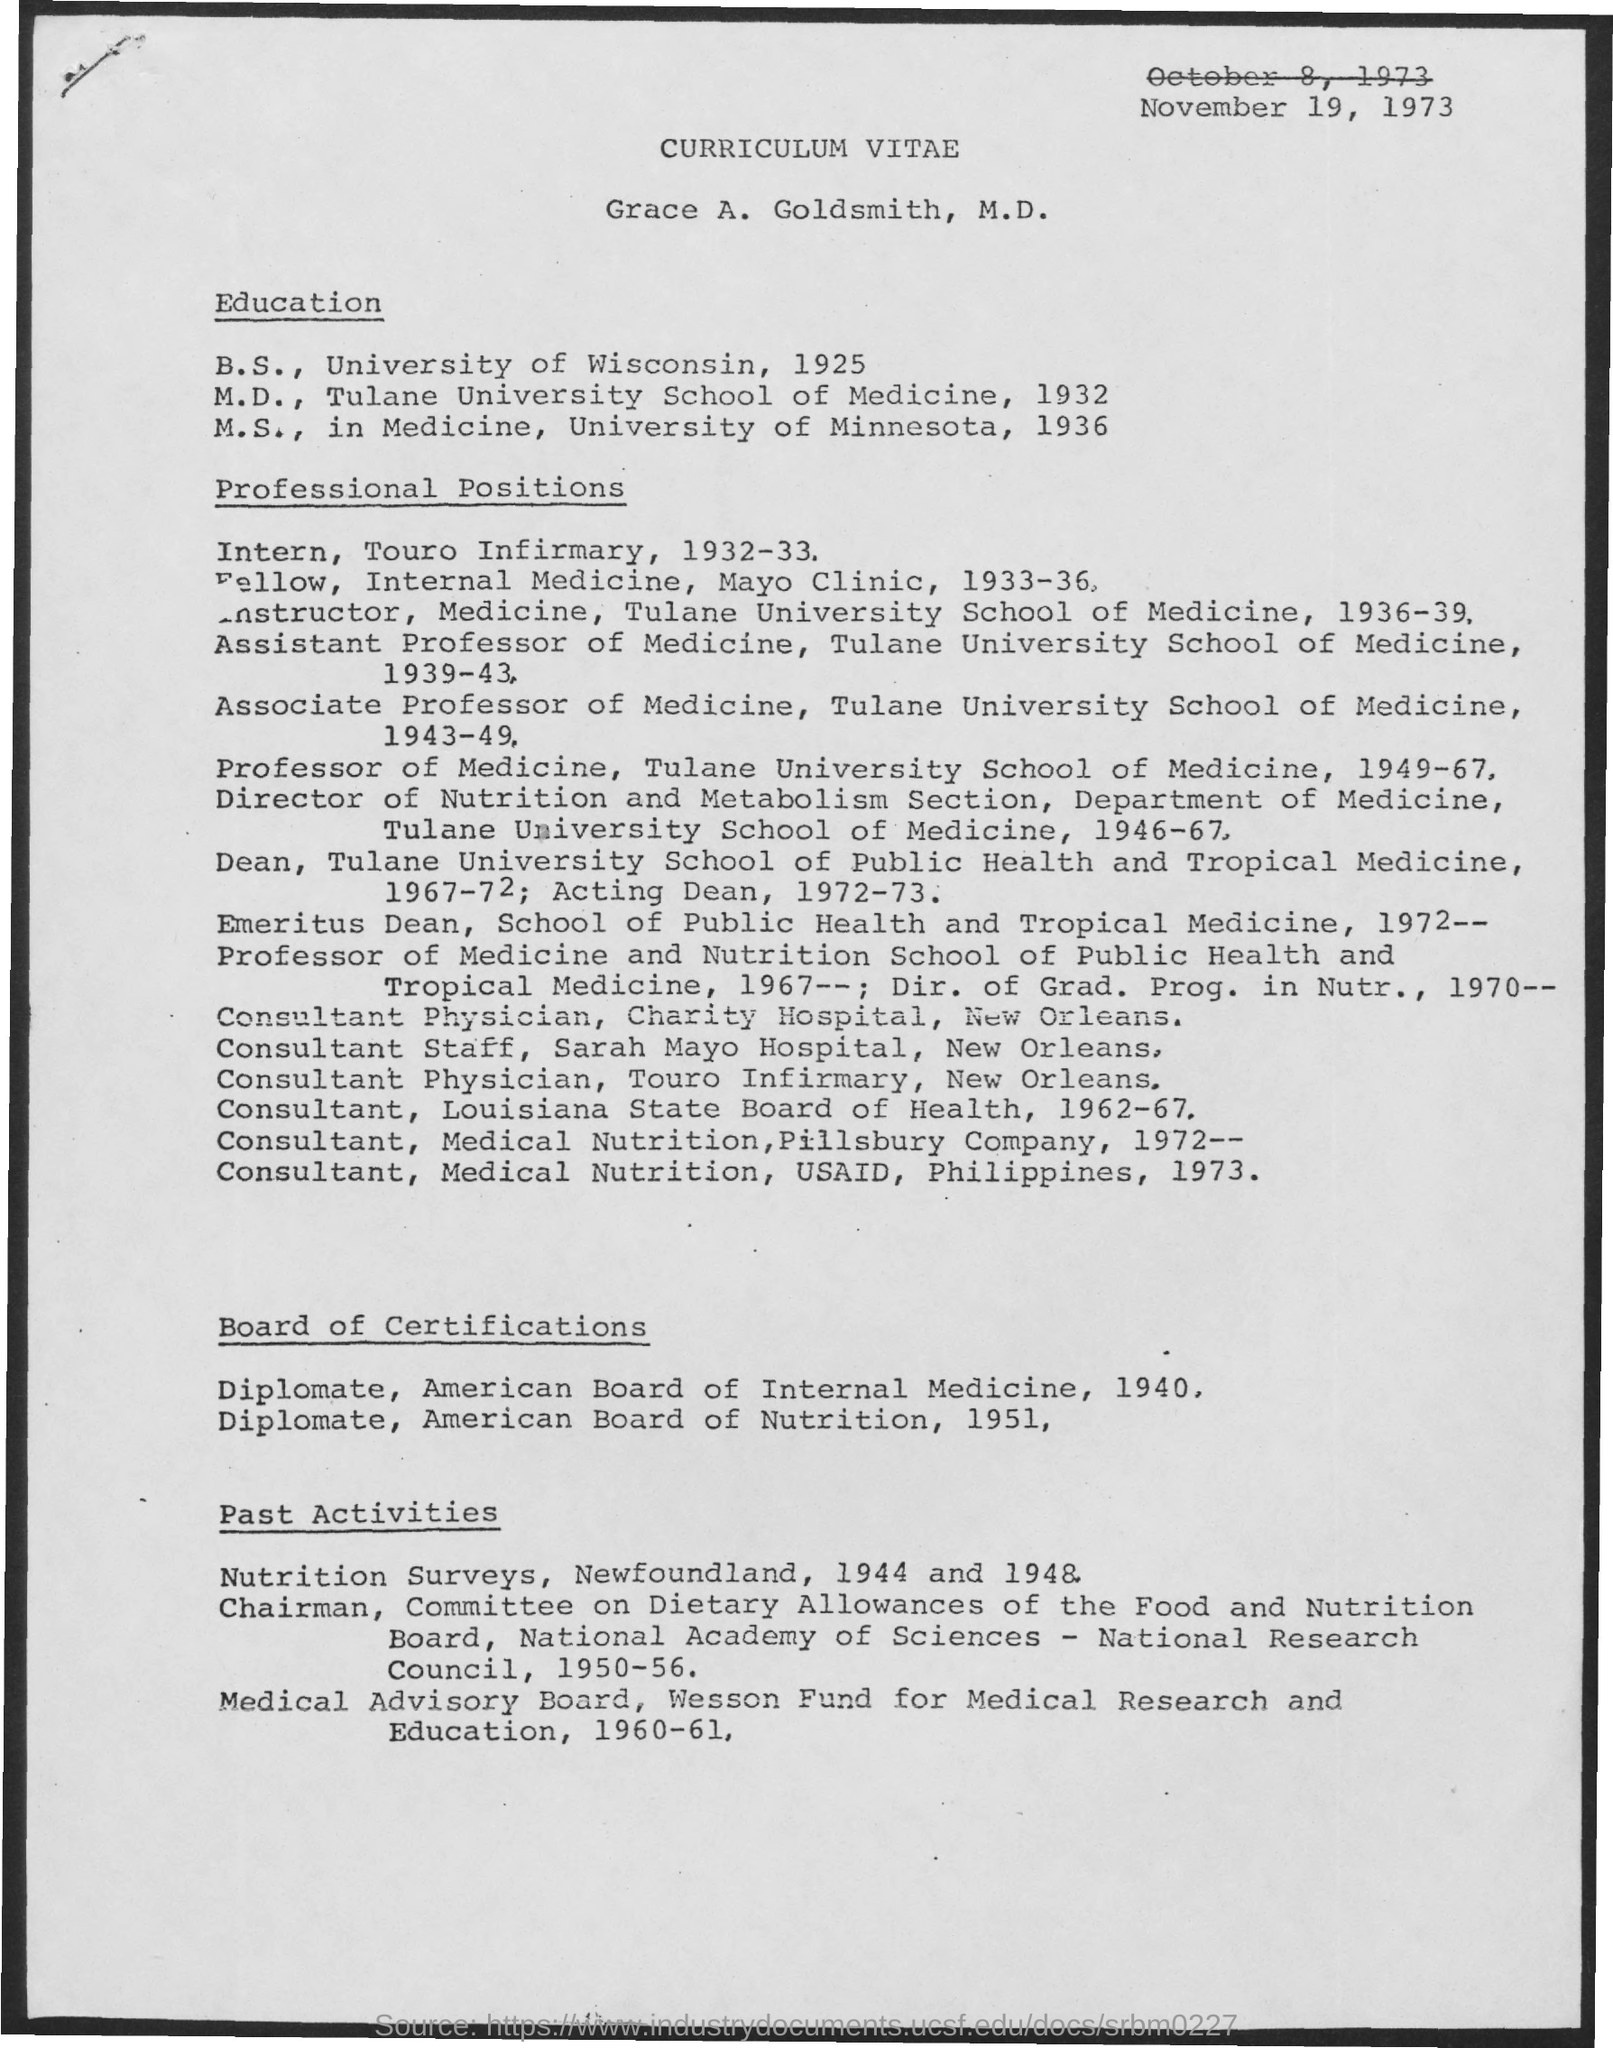What is the date mentioned in the curriculum vitae ?
Provide a succinct answer. November 19, 1973. What is the name mentioned in the curriculum vitae ?
Provide a short and direct response. Grace A. Goldsmith, M.D. From which university he completed his b.s as shown in the curriculum vitae ?
Offer a very short reply. University of Wisconsin. In which year he completed his m.d ?
Your response must be concise. 1932. From which university he completed his m.s ?
Offer a very short reply. University of Minnesota. In which field he completed his m.s ?
Your response must be concise. MEDICINE. In which year he completed his b.s ?
Keep it short and to the point. 1925. In which year he completed his m.s according to curriculum vitae ?
Keep it short and to the point. 1936. In which year he completed his diplomate,in american board of internal medicine ?
Keep it short and to the point. 1940. 